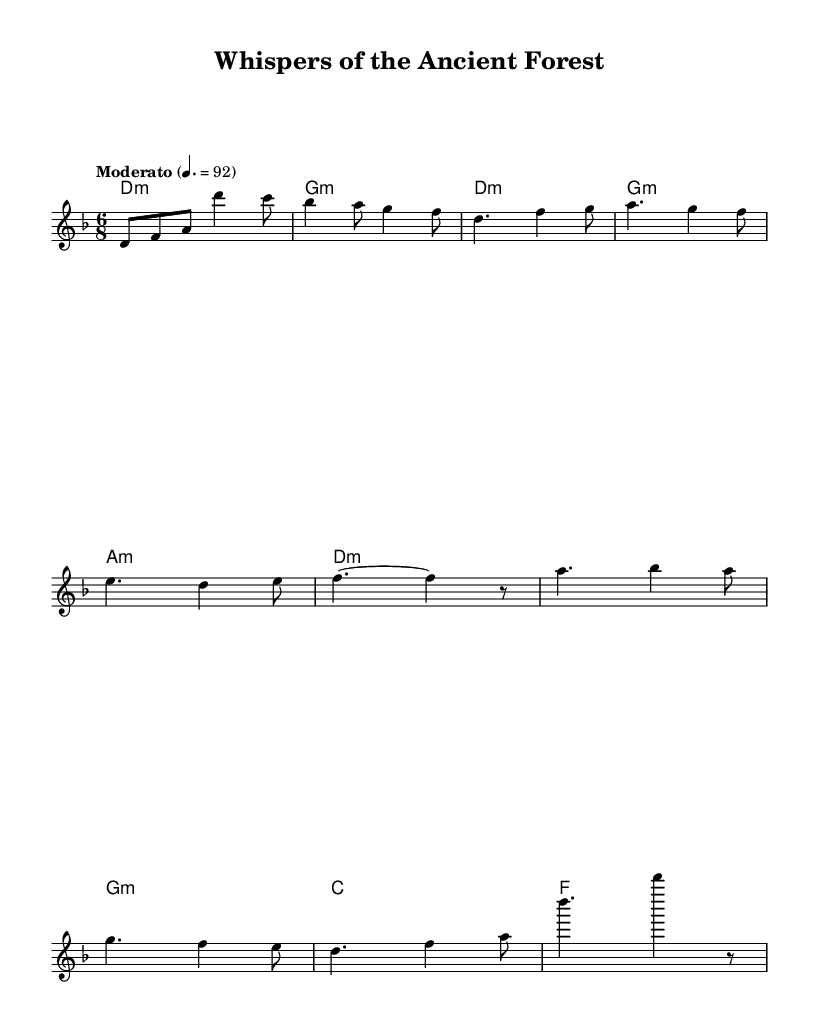What is the key signature of this music? The key signature shows two flats, indicating it is in D minor.
Answer: D minor What is the time signature of the piece? The time signature is located at the beginning of the score, indicating it is 6/8, which signifies six eighth notes per measure.
Answer: 6/8 What is the indicated tempo for this piece? The tempo marking shows "Moderato" with a beat of 92, meaning the piece should be played at a moderate speed of 92 beats per minute.
Answer: 92 How many measures are in the intro section? Counting the measures in the score, there are two measures indicated in the intro section before the verse starts, which is shown in the melody part.
Answer: 2 What type of chords are mainly used in this piece? By examining the harmonies, we see that the fundamental chord type is minor, consistently appearing throughout the sections, providing a somber and introspective quality fitting to the theme.
Answer: Minor Which section uses the longest note values? The verse section uses dotted half notes and longer holds in the melody, indicating sustained phrases for expressive purposes, further evidenced by looking at the rhythmic notations throughout the score.
Answer: Verse What is the primary musical theme of this piece? The piece's title, "Whispers of the Ancient Forest," along with the harmonization and melodic contours, suggests that it aims to evoke a mystical, nature-inspired feeling, reflective of the electro-folk fusion genre's characteristics.
Answer: Ancient forest 